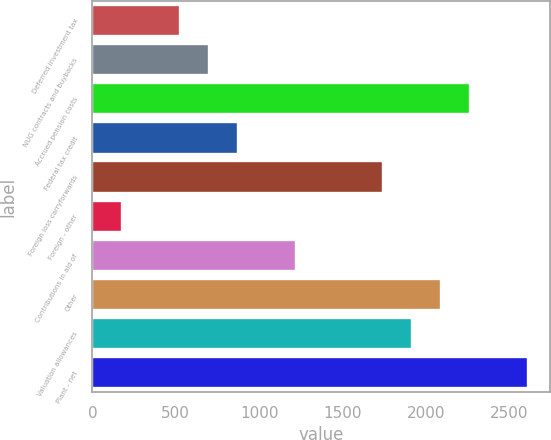Convert chart. <chart><loc_0><loc_0><loc_500><loc_500><bar_chart><fcel>Deferred investment tax<fcel>NUG contracts and buybacks<fcel>Accrued pension costs<fcel>Federal tax credit<fcel>Foreign loss carryforwards<fcel>Foreign - other<fcel>Contributions in aid of<fcel>Other<fcel>Valuation allowances<fcel>Plant - net<nl><fcel>527.4<fcel>701.2<fcel>2265.4<fcel>875<fcel>1744<fcel>179.8<fcel>1222.6<fcel>2091.6<fcel>1917.8<fcel>2613<nl></chart> 